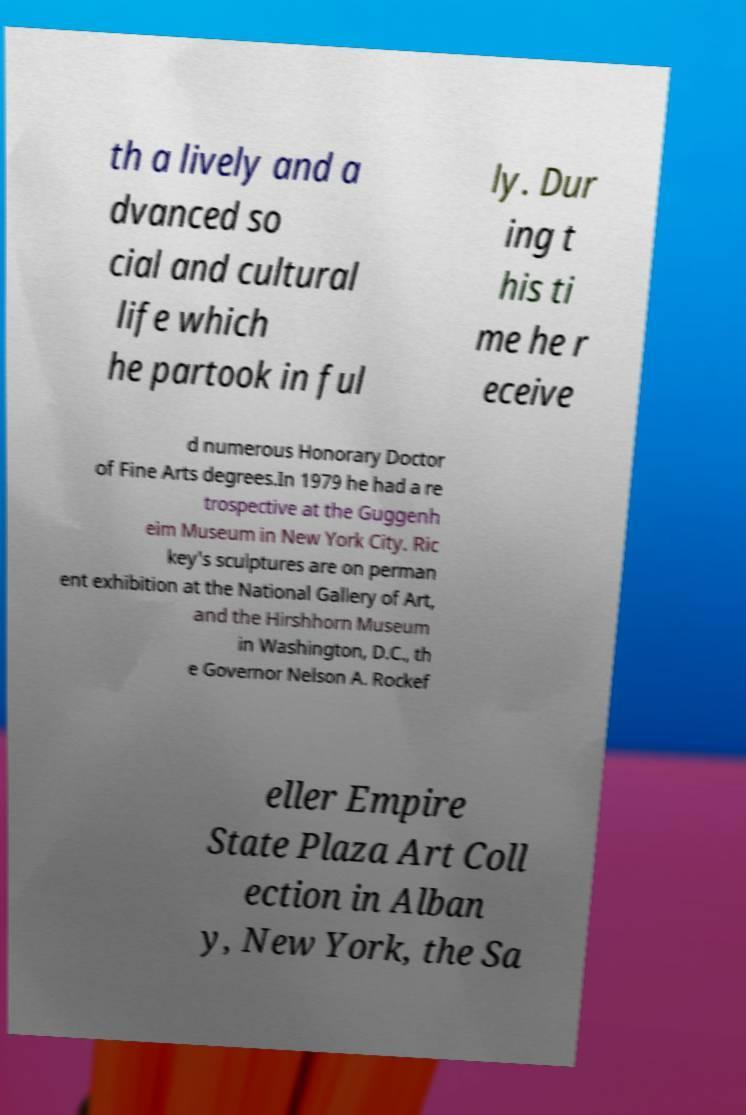I need the written content from this picture converted into text. Can you do that? th a lively and a dvanced so cial and cultural life which he partook in ful ly. Dur ing t his ti me he r eceive d numerous Honorary Doctor of Fine Arts degrees.In 1979 he had a re trospective at the Guggenh eim Museum in New York City. Ric key's sculptures are on perman ent exhibition at the National Gallery of Art, and the Hirshhorn Museum in Washington, D.C., th e Governor Nelson A. Rockef eller Empire State Plaza Art Coll ection in Alban y, New York, the Sa 